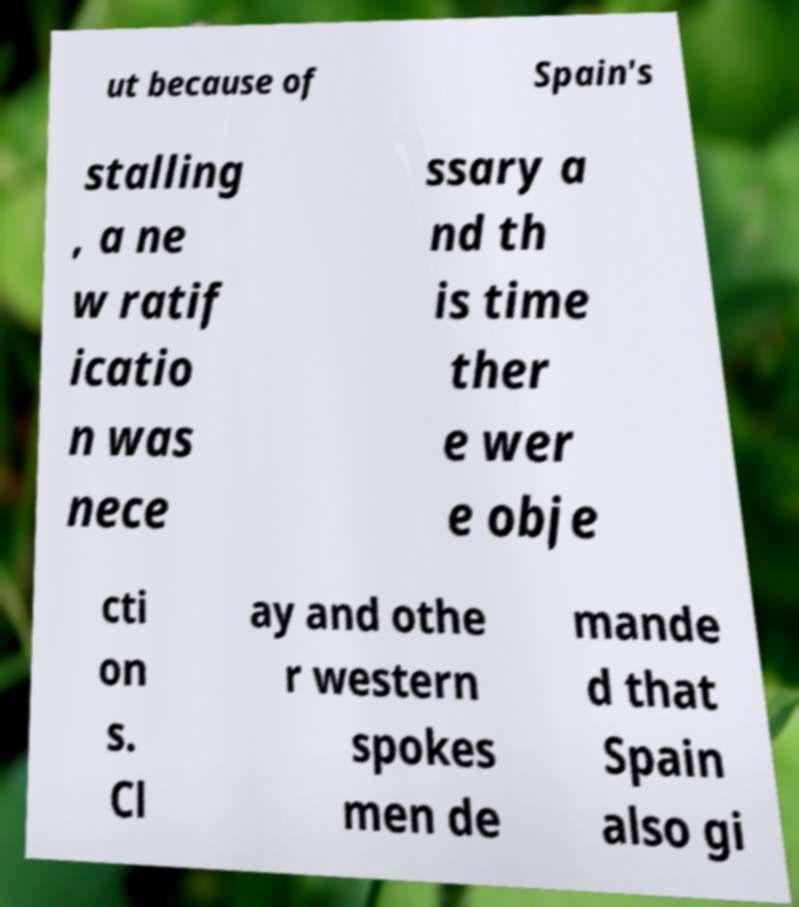Could you extract and type out the text from this image? ut because of Spain's stalling , a ne w ratif icatio n was nece ssary a nd th is time ther e wer e obje cti on s. Cl ay and othe r western spokes men de mande d that Spain also gi 